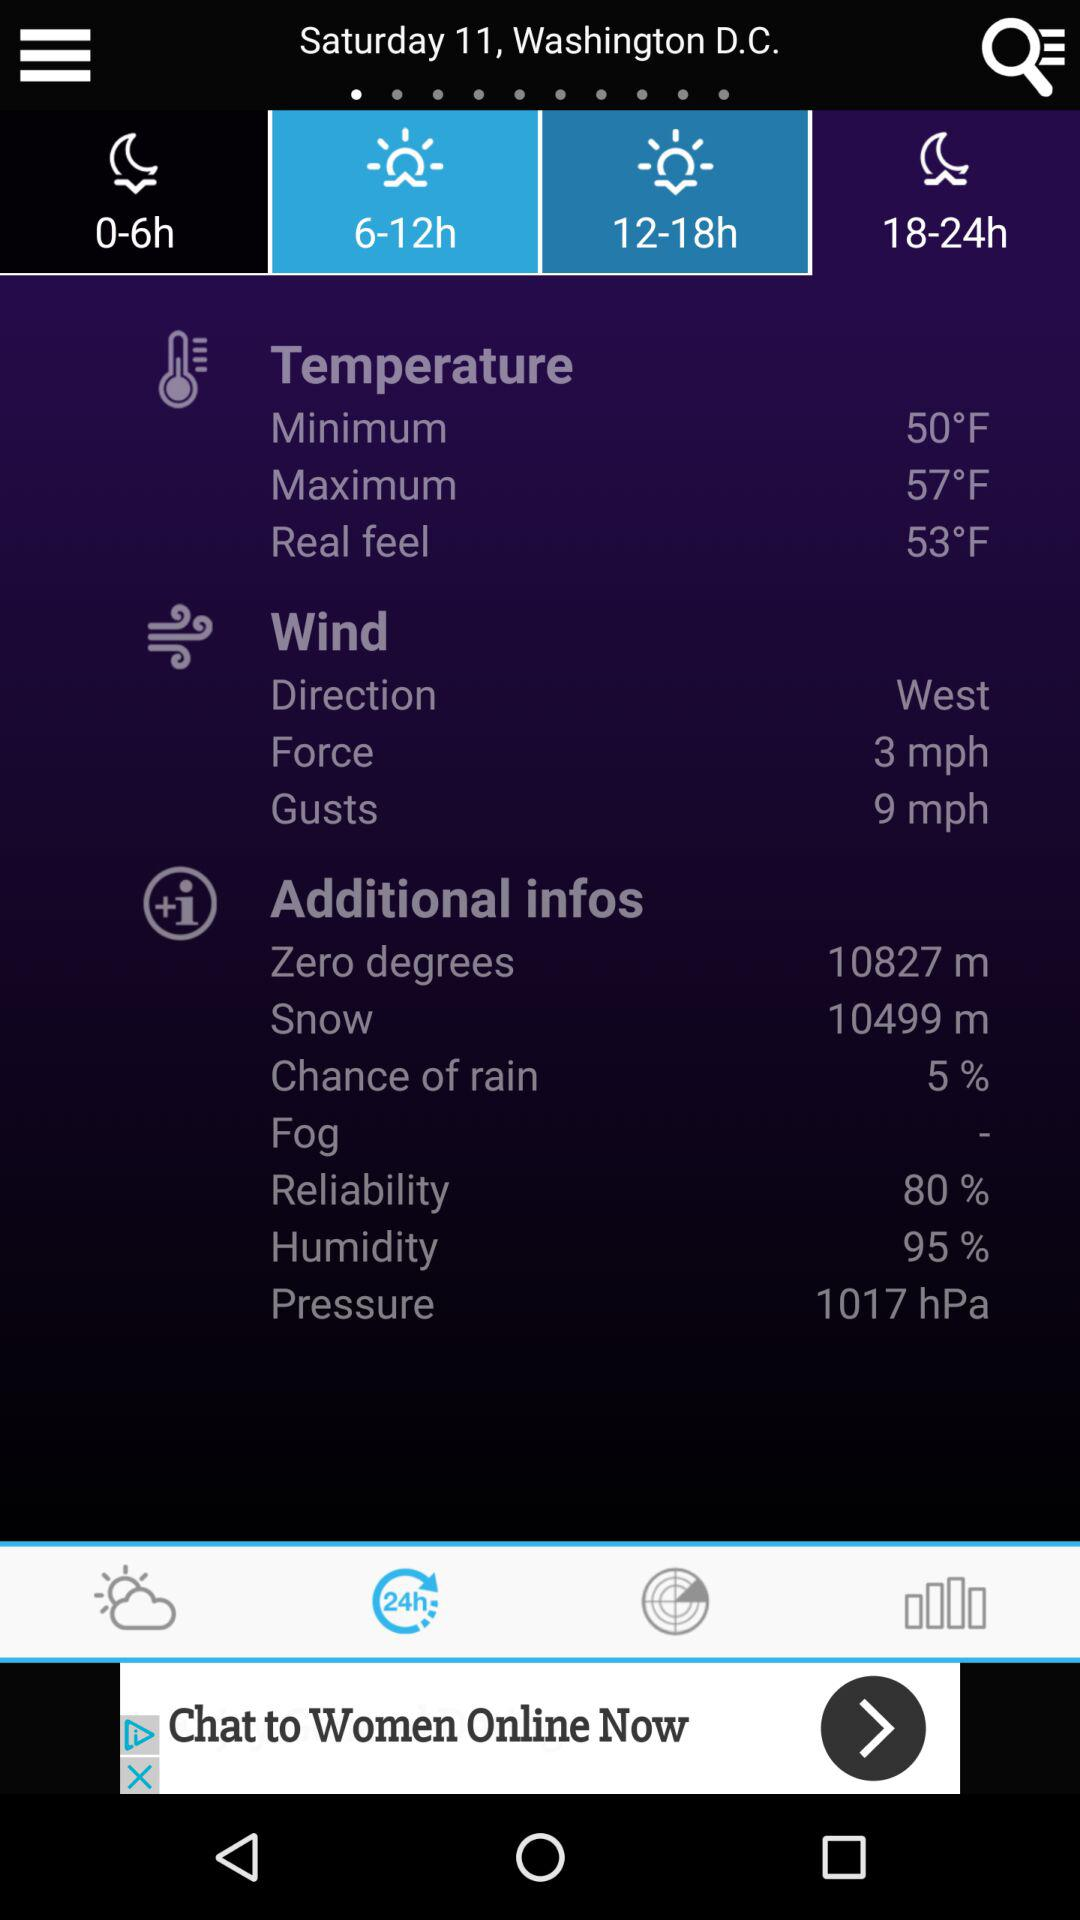What is the difference in force between the wind and the gusts?
Answer the question using a single word or phrase. 6 mph 